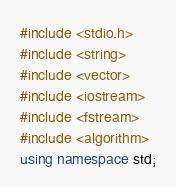Convert code to text. <code><loc_0><loc_0><loc_500><loc_500><_C++_>#include <stdio.h>
#include <string>
#include <vector>
#include <iostream>
#include <fstream>
#include <algorithm>
using namespace std;
</code> 